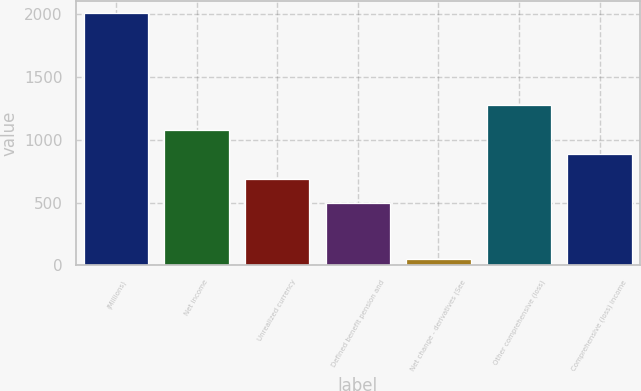Convert chart. <chart><loc_0><loc_0><loc_500><loc_500><bar_chart><fcel>(Millions)<fcel>Net income<fcel>Unrealized currency<fcel>Defined benefit pension and<fcel>Net change - derivatives (See<fcel>Other comprehensive (loss)<fcel>Comprehensive (loss) income<nl><fcel>2008<fcel>1081.7<fcel>689.9<fcel>494<fcel>49<fcel>1277.6<fcel>885.8<nl></chart> 